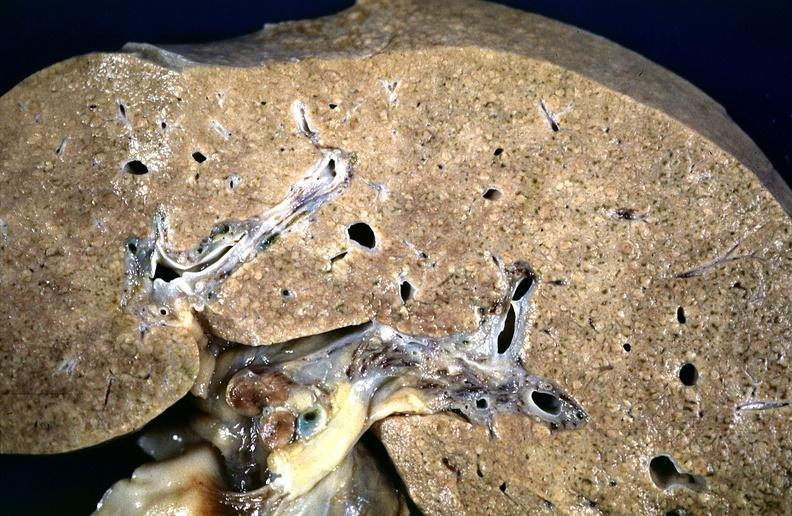what is present?
Answer the question using a single word or phrase. Liver 